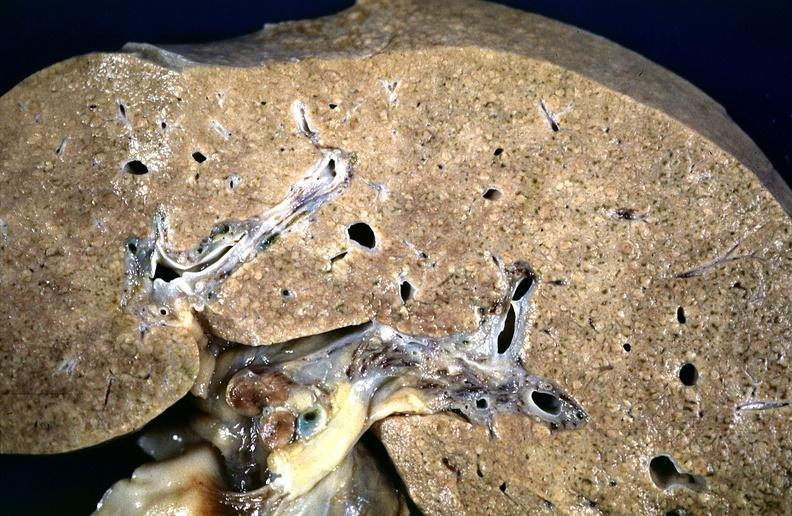what is present?
Answer the question using a single word or phrase. Liver 